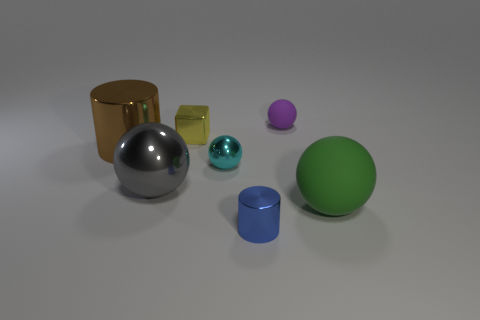Does the brown thing have the same size as the sphere that is in front of the big metal ball?
Ensure brevity in your answer.  Yes. What is the size of the metal cylinder that is on the left side of the tiny sphere that is in front of the metallic cylinder behind the gray metallic sphere?
Your response must be concise. Large. There is a metal cylinder behind the large gray sphere; what is its size?
Your response must be concise. Large. What is the shape of the yellow thing that is the same material as the gray ball?
Ensure brevity in your answer.  Cube. Are the big sphere that is to the right of the purple object and the yellow cube made of the same material?
Your response must be concise. No. How many other things are made of the same material as the yellow cube?
Provide a short and direct response. 4. What number of things are large things left of the yellow object or big metallic things that are in front of the small cyan metallic object?
Provide a succinct answer. 2. Does the object in front of the big green matte thing have the same shape as the matte object on the left side of the green ball?
Your answer should be very brief. No. There is a purple rubber thing that is the same size as the yellow shiny thing; what is its shape?
Offer a terse response. Sphere. How many rubber things are either big yellow blocks or large cylinders?
Provide a succinct answer. 0. 